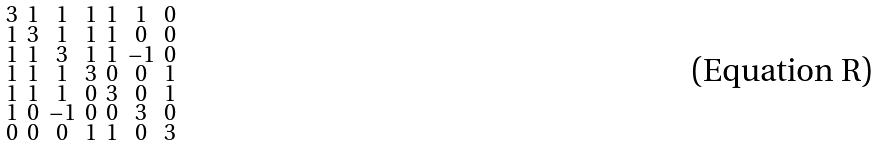Convert formula to latex. <formula><loc_0><loc_0><loc_500><loc_500>\begin{smallmatrix} 3 & 1 & 1 & 1 & 1 & 1 & 0 \\ 1 & 3 & 1 & 1 & 1 & 0 & 0 \\ 1 & 1 & 3 & 1 & 1 & - 1 & 0 \\ 1 & 1 & 1 & 3 & 0 & 0 & 1 \\ 1 & 1 & 1 & 0 & 3 & 0 & 1 \\ 1 & 0 & - 1 & 0 & 0 & 3 & 0 \\ 0 & 0 & 0 & 1 & 1 & 0 & 3 \end{smallmatrix}</formula> 